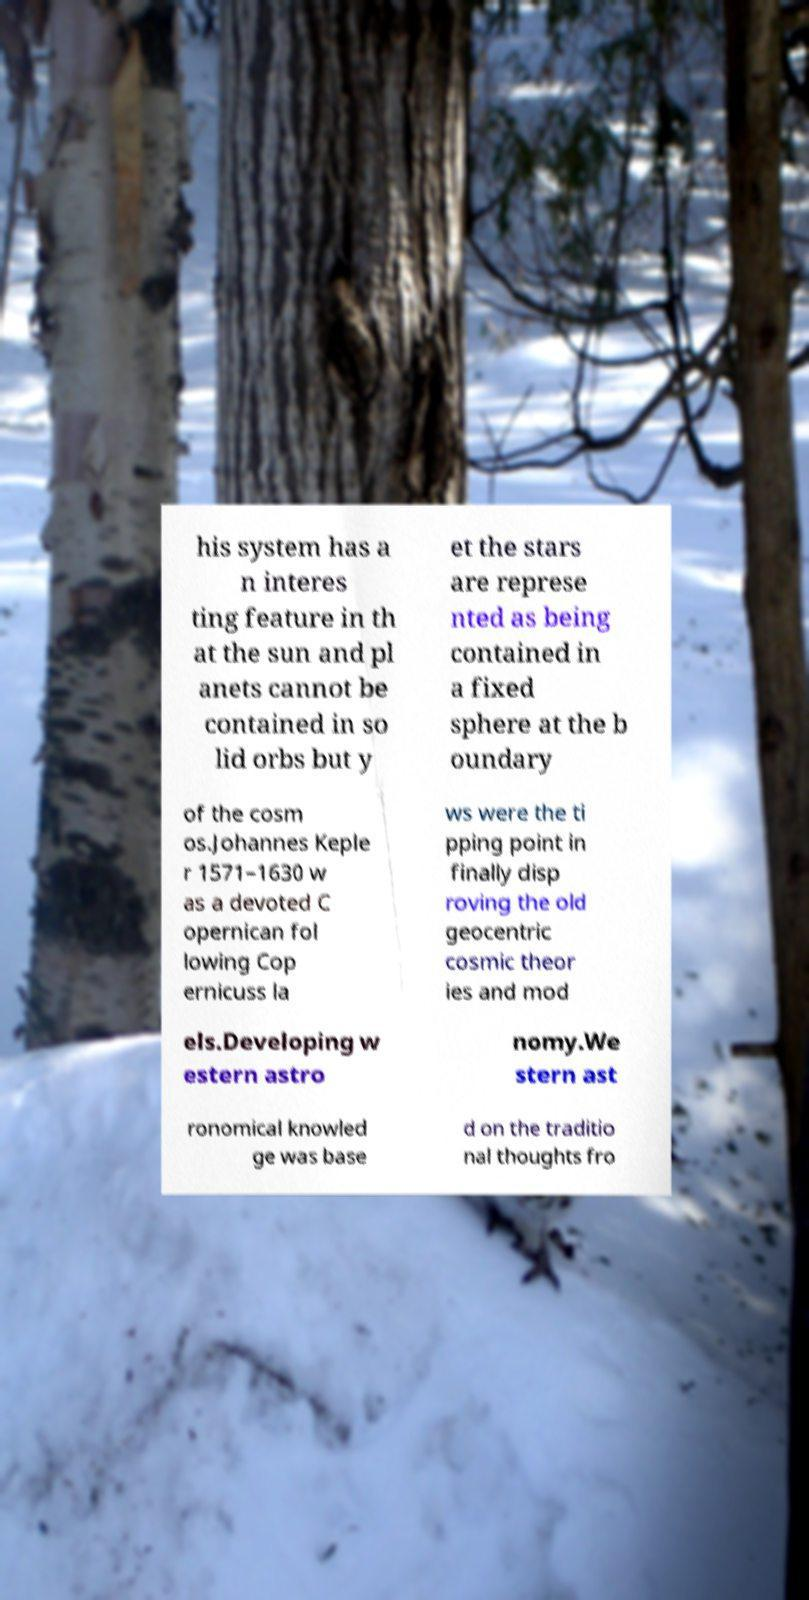What messages or text are displayed in this image? I need them in a readable, typed format. his system has a n interes ting feature in th at the sun and pl anets cannot be contained in so lid orbs but y et the stars are represe nted as being contained in a fixed sphere at the b oundary of the cosm os.Johannes Keple r 1571–1630 w as a devoted C opernican fol lowing Cop ernicuss la ws were the ti pping point in finally disp roving the old geocentric cosmic theor ies and mod els.Developing w estern astro nomy.We stern ast ronomical knowled ge was base d on the traditio nal thoughts fro 